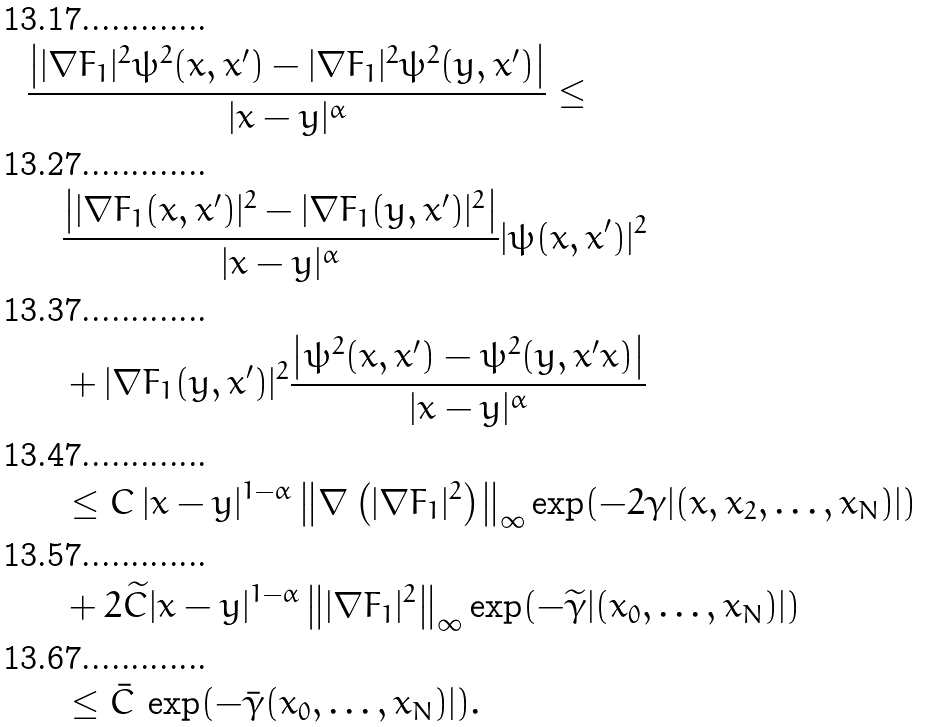<formula> <loc_0><loc_0><loc_500><loc_500>& \frac { \left | | \nabla F _ { 1 } | ^ { 2 } \psi ^ { 2 } ( x , x ^ { \prime } ) - | \nabla F _ { 1 } | ^ { 2 } \psi ^ { 2 } ( y , x ^ { \prime } ) \right | } { | x - y | ^ { \alpha } } \leq \\ & \quad \frac { \left | | \nabla F _ { 1 } ( x , x ^ { \prime } ) | ^ { 2 } - | \nabla F _ { 1 } ( y , x ^ { \prime } ) | ^ { 2 } \right | } { | x - y | ^ { \alpha } } | \psi ( x , x ^ { \prime } ) | ^ { 2 } \\ & \quad + | \nabla F _ { 1 } ( y , x ^ { \prime } ) | ^ { 2 } \frac { \left | \psi ^ { 2 } ( x , x ^ { \prime } ) - \psi ^ { 2 } ( y , x ^ { \prime } x ) \right | } { | x - y | ^ { \alpha } } \\ & \quad \leq C \, | x - y | ^ { 1 - \alpha } \left \| \nabla \left ( | \nabla F _ { 1 } | ^ { 2 } \right ) \right \| _ { \infty } \exp ( - 2 \gamma | ( x , x _ { 2 } , \dots , x _ { N } ) | ) \\ & \quad + 2 \widetilde { C } | x - y | ^ { 1 - \alpha } \left \| | \nabla F _ { 1 } | ^ { 2 } \right \| _ { \infty } \exp ( - \widetilde { \gamma } | ( x _ { 0 } , \dots , x _ { N } ) | ) \\ & \quad \leq \bar { C } \, \exp ( - \bar { \gamma } ( x _ { 0 } , \dots , x _ { N } ) | ) .</formula> 